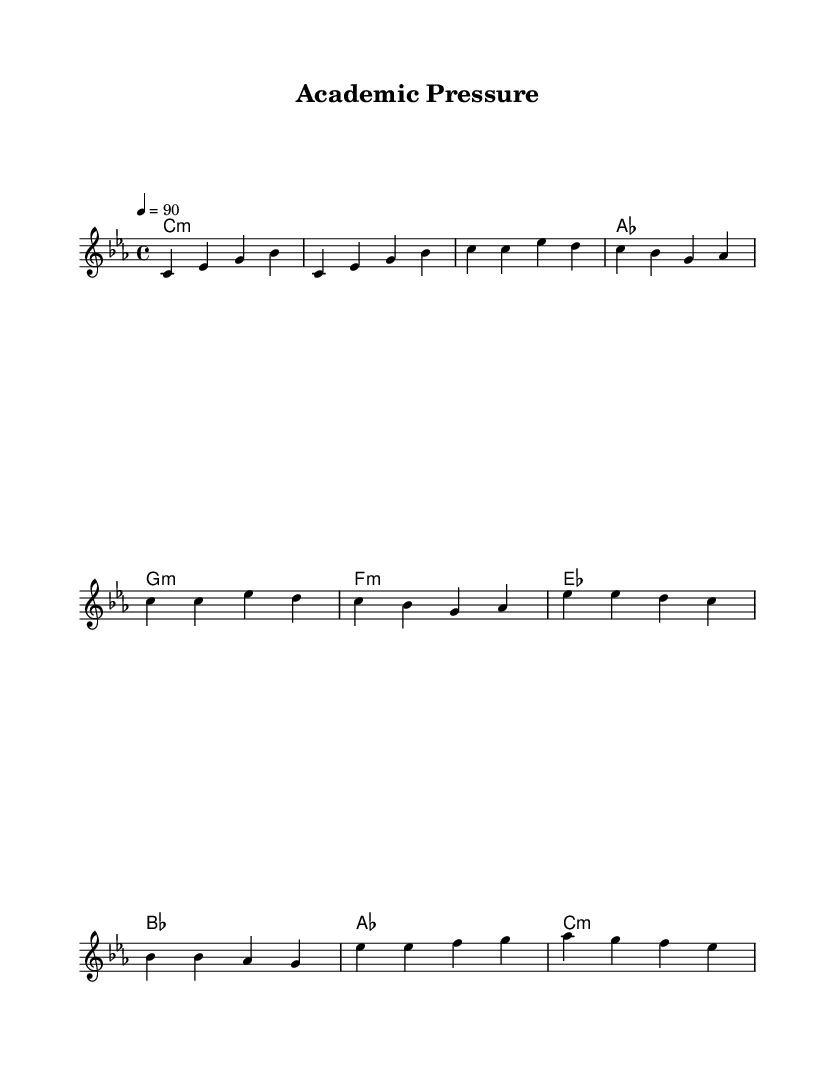What is the key signature of this music? The key signature is C minor, which has three flats (B flat, E flat, and A flat). This is evident from the initial indication in the score and affects all notes accordingly.
Answer: C minor What is the time signature of this music? The time signature is 4/4, indicated in the beginning of the score. This means there are four beats per measure, and the quarter note gets one beat.
Answer: 4/4 What is the tempo marking of this music? The tempo marking is quarter note equals ninety beats per minute, shown in the header. This implies a moderate pace for the rap performance.
Answer: 90 Which section comes first in this piece? The first section is the "Intro," as indicated at the beginning of the melody, with specific chords and notes laid out before transitioning into verses.
Answer: Intro How many times is the verse repeated? The verse is repeated twice, as indicated by the command to "repeat unfold 2" within the melody section. This signals that the sequence is played two times in succession.
Answer: 2 What is the primary mood of this rap piece based on its musical structure? The primary mood can be described as introspective and reflective, as suggested by the choice of minor key and the thematic content mentioned in the title of the piece, "Academic Pressure." The key of C minor often conveys a sense of seriousness or melancholy.
Answer: Introspective 